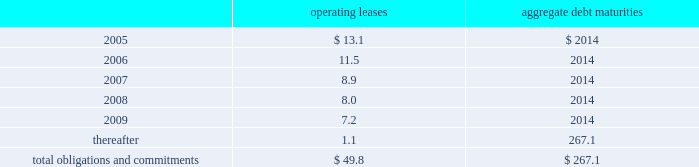Edwards lifesciences corporation notes to consolidated financial statements 2014 ( continued ) future minimum lease payments ( including interest ) under noncancelable operating leases and aggregate debt maturities at december 31 , 2004 were as follows ( in millions ) : aggregate operating debt leases maturities 2005*************************************************************** $ 13.1 $ 2014 2006*************************************************************** 11.5 2014 2007*************************************************************** 8.9 2014 2008*************************************************************** 8.0 2014 2009*************************************************************** 7.2 2014 thereafter ********************************************************** 1.1 267.1 total obligations and commitments************************************** $ 49.8 $ 267.1 included in debt at december 31 , 2004 and 2003 were unsecured notes denominated in japanese yen of a57.0 billion ( us$ 67.1 million ) and a56.0 billion ( us$ 55.8 million ) , respectively .
Certain facilities and equipment are leased under operating leases expiring at various dates .
Most of the operating leases contain renewal options .
Total expense for all operating leases was $ 14.0 million , $ 12.3 million , and $ 6.8 million for the years 2004 , 2003 and 2002 , respectively .
11 .
Financial instruments and risk management fair values of financial instruments the consolidated financial statements include financial instruments whereby the fair market value of such instruments may differ from amounts reflected on a historical basis .
Financial instruments of the company consist of cash deposits , accounts and other receivables , investments in unconsolidated affiliates , accounts payable , certain accrued liabilities and debt .
The fair values of certain investments in unconsolidated affiliates are estimated based on quoted market prices .
For other investments , various methods are used to estimate fair value , including external valuations and discounted cash flows .
The carrying amount of the company 2019s long-term debt approximates fair market value based on prevailing market rates .
The company 2019s other financial instruments generally approximate their fair values based on the short-term nature of these instruments. .
Edwards lifesciences corporation notes to consolidated financial statements 2014 ( continued ) future minimum lease payments ( including interest ) under noncancelable operating leases and aggregate debt maturities at december 31 , 2004 were as follows ( in millions ) : aggregate operating debt leases maturities 2005*************************************************************** $ 13.1 $ 2014 2006*************************************************************** 11.5 2014 2007*************************************************************** 8.9 2014 2008*************************************************************** 8.0 2014 2009*************************************************************** 7.2 2014 thereafter ********************************************************** 1.1 267.1 total obligations and commitments************************************** $ 49.8 $ 267.1 included in debt at december 31 , 2004 and 2003 were unsecured notes denominated in japanese yen of a57.0 billion ( us$ 67.1 million ) and a56.0 billion ( us$ 55.8 million ) , respectively .
Certain facilities and equipment are leased under operating leases expiring at various dates .
Most of the operating leases contain renewal options .
Total expense for all operating leases was $ 14.0 million , $ 12.3 million , and $ 6.8 million for the years 2004 , 2003 and 2002 , respectively .
11 .
Financial instruments and risk management fair values of financial instruments the consolidated financial statements include financial instruments whereby the fair market value of such instruments may differ from amounts reflected on a historical basis .
Financial instruments of the company consist of cash deposits , accounts and other receivables , investments in unconsolidated affiliates , accounts payable , certain accrued liabilities and debt .
The fair values of certain investments in unconsolidated affiliates are estimated based on quoted market prices .
For other investments , various methods are used to estimate fair value , including external valuations and discounted cash flows .
The carrying amount of the company 2019s long-term debt approximates fair market value based on prevailing market rates .
The company 2019s other financial instruments generally approximate their fair values based on the short-term nature of these instruments. .
What was the percentage change in total expense for all operating leases between 2002 and 2003? 
Computations: ((12.3 - 6.8) / 6.8)
Answer: 0.80882. 